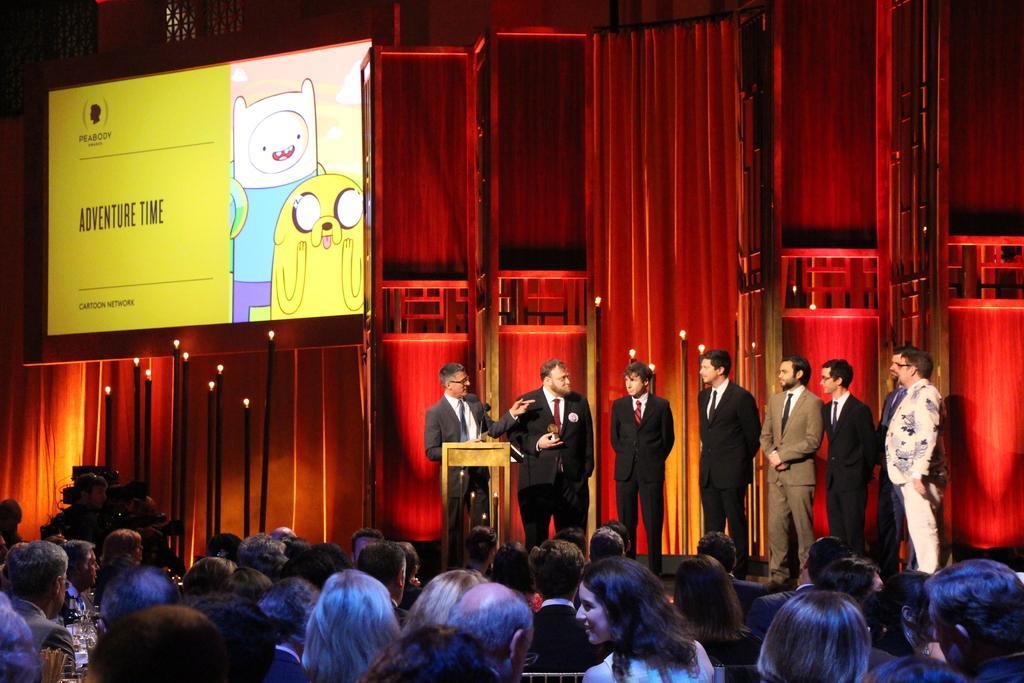In one or two sentences, can you explain what this image depicts? In this image there are eight people wearing suits and standing on the stage. The background is fully in red color. There are also lights visible. Screen is also present. At the bottom there are people sitting. 